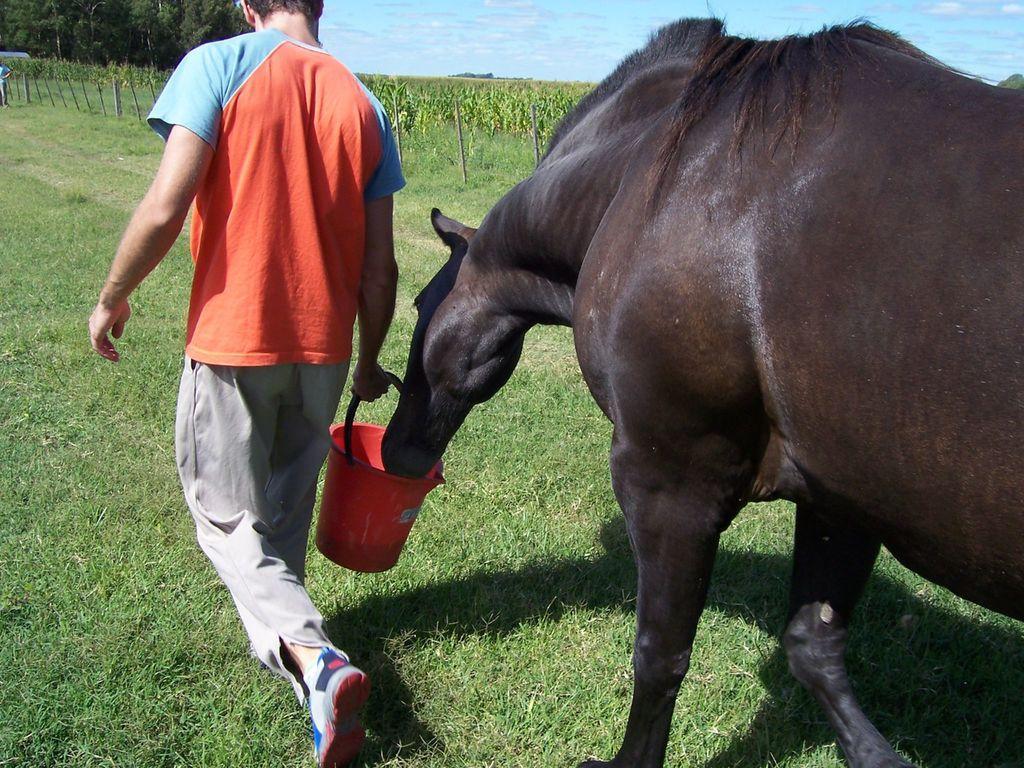Describe this image in one or two sentences. In this image we can see the man holding bucket, on the right we can see an animal, we can see trees, grass, at the top we can see the sky. 